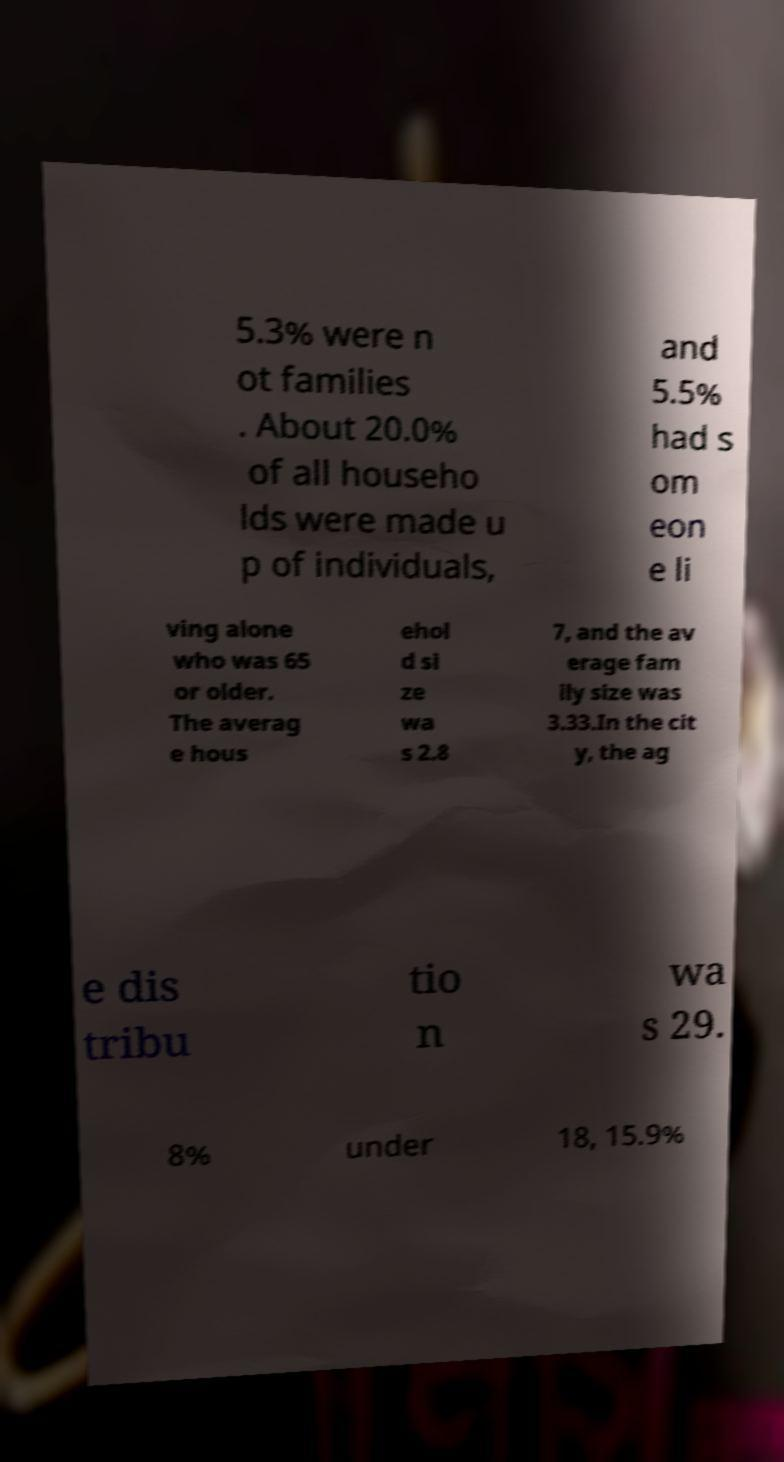For documentation purposes, I need the text within this image transcribed. Could you provide that? 5.3% were n ot families . About 20.0% of all househo lds were made u p of individuals, and 5.5% had s om eon e li ving alone who was 65 or older. The averag e hous ehol d si ze wa s 2.8 7, and the av erage fam ily size was 3.33.In the cit y, the ag e dis tribu tio n wa s 29. 8% under 18, 15.9% 